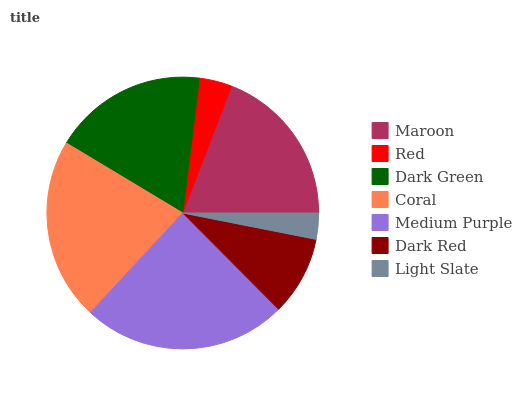Is Light Slate the minimum?
Answer yes or no. Yes. Is Medium Purple the maximum?
Answer yes or no. Yes. Is Red the minimum?
Answer yes or no. No. Is Red the maximum?
Answer yes or no. No. Is Maroon greater than Red?
Answer yes or no. Yes. Is Red less than Maroon?
Answer yes or no. Yes. Is Red greater than Maroon?
Answer yes or no. No. Is Maroon less than Red?
Answer yes or no. No. Is Dark Green the high median?
Answer yes or no. Yes. Is Dark Green the low median?
Answer yes or no. Yes. Is Maroon the high median?
Answer yes or no. No. Is Maroon the low median?
Answer yes or no. No. 